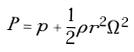<formula> <loc_0><loc_0><loc_500><loc_500>P = p + \frac { 1 } { 2 } \rho r ^ { 2 } \Omega ^ { 2 }</formula> 